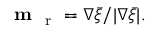<formula> <loc_0><loc_0><loc_500><loc_500>m _ { r } = \nabla \bar { \xi } / | \nabla \bar { \xi } | .</formula> 